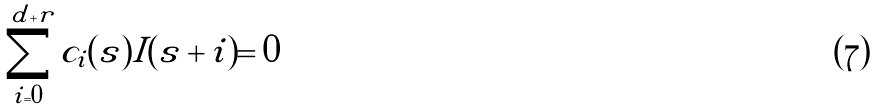Convert formula to latex. <formula><loc_0><loc_0><loc_500><loc_500>\sum _ { i = 0 } ^ { d + r } c _ { i } ( s ) I ( s + i ) = 0</formula> 